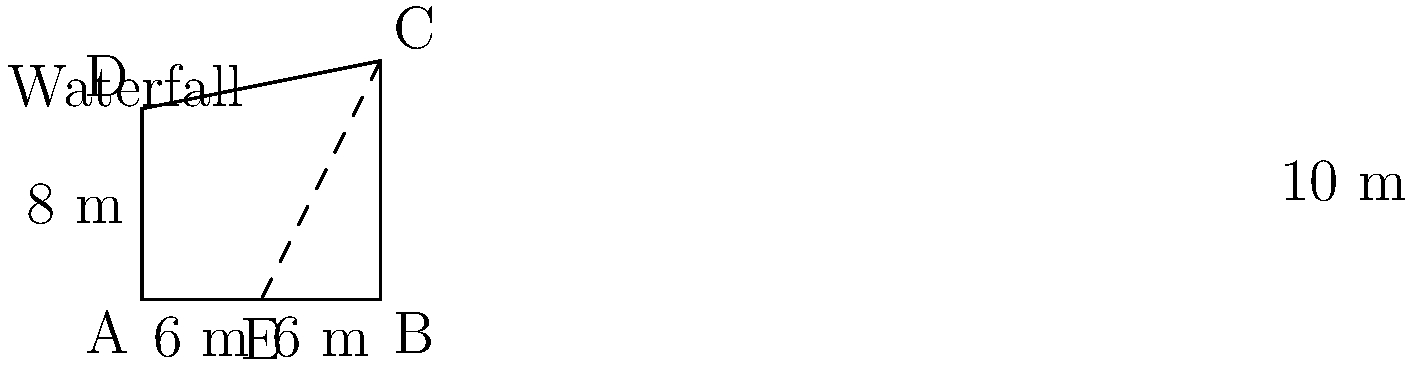As part of showcasing the natural beauty of the area, you need to measure the height of a magnificent waterfall. Due to the terrain, direct measurement is impossible. You set up a 12-meter stick (AB) parallel to the base of the waterfall, with its midpoint (E) directly below the top of the waterfall (C). From the end of the stick (B), you measure the angle to the top of the waterfall to be 45°. Standing at point D, 8 meters back from the stick, you can see both the top (C) and bottom (A) of the waterfall. What is the height of the waterfall? Let's approach this step-by-step using similar triangles:

1) In triangle BCE:
   - BE = 6 m (half of the 12-meter stick)
   - Angle CBE = 45°
   - Therefore, BCE is an isosceles right triangle
   - BC = BE = 6 m

2) Now, we have two similar triangles: ABC and ADE
   - They share an angle at A
   - Both have a right angle (at B and D respectively)

3) We can set up a proportion:
   $\frac{BC}{DE} = \frac{AB}{AD}$

4) We know:
   - BC = 10 m (6 m + 4 m from step 1)
   - AB = 12 m
   - AD = 8 m (given in the problem)

5) Let's call the height of the waterfall (DE) h:
   $\frac{10}{h} = \frac{12}{8}$

6) Cross multiply:
   $8 \cdot 10 = 12h$

7) Solve for h:
   $h = \frac{8 \cdot 10}{12} = \frac{80}{12} = \frac{20}{3} \approx 6.67$ m

Therefore, the height of the waterfall is $\frac{20}{3}$ meters or approximately 6.67 meters.
Answer: $\frac{20}{3}$ m 